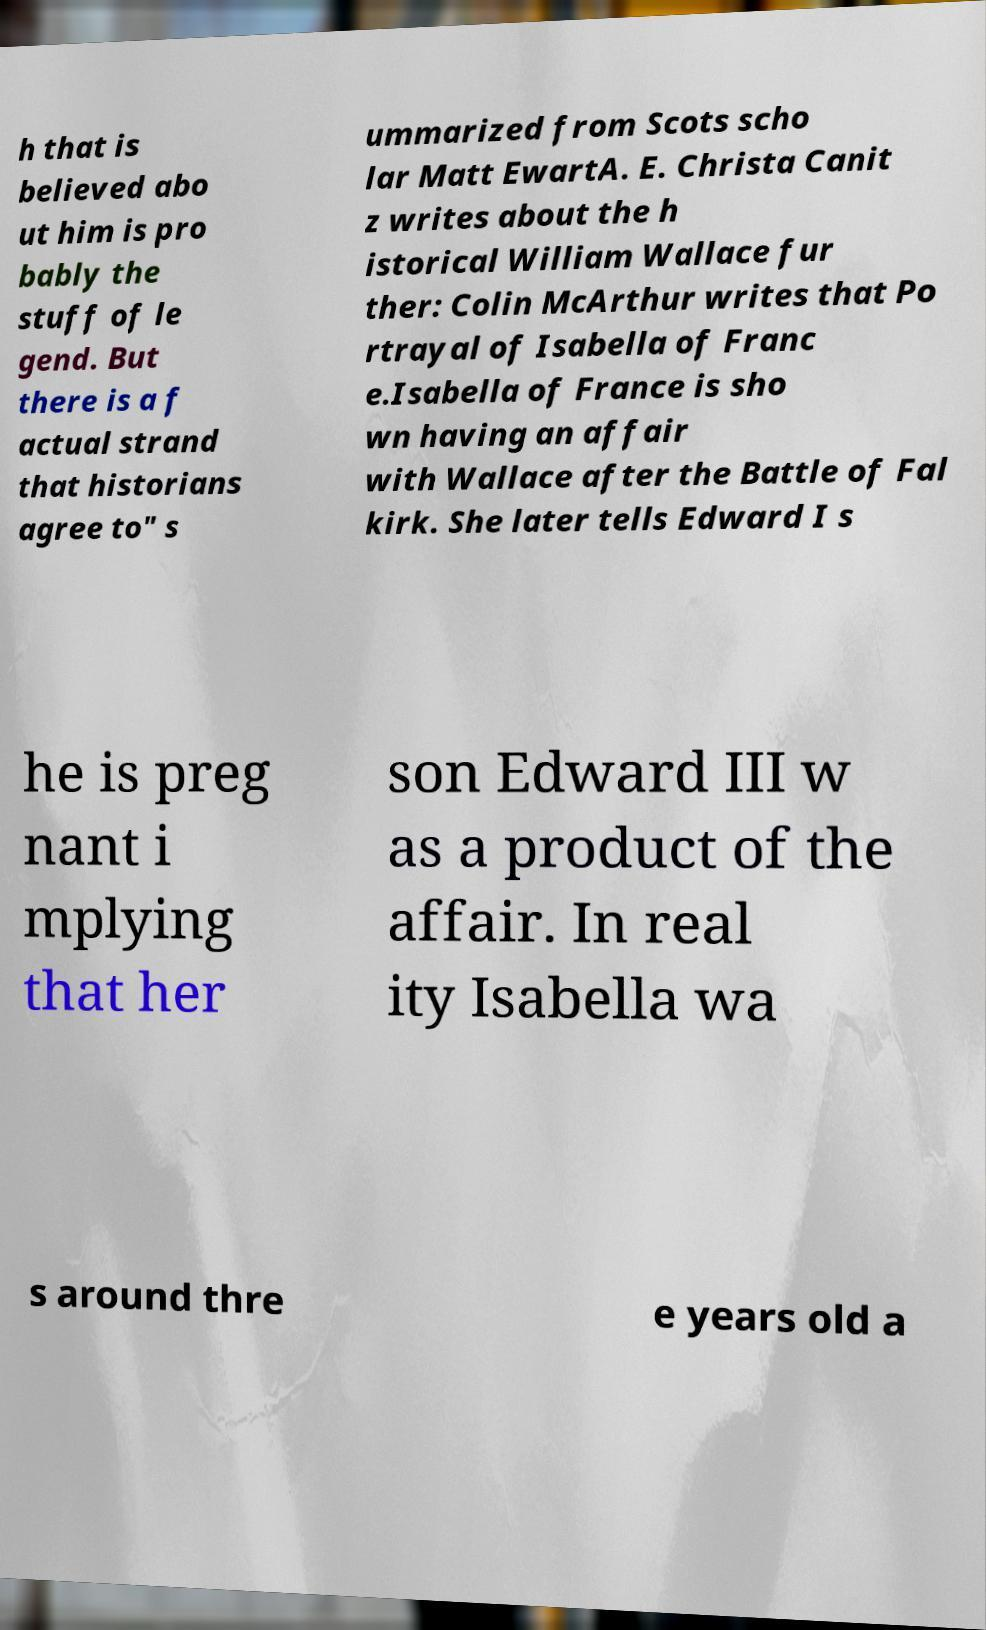Could you extract and type out the text from this image? h that is believed abo ut him is pro bably the stuff of le gend. But there is a f actual strand that historians agree to" s ummarized from Scots scho lar Matt EwartA. E. Christa Canit z writes about the h istorical William Wallace fur ther: Colin McArthur writes that Po rtrayal of Isabella of Franc e.Isabella of France is sho wn having an affair with Wallace after the Battle of Fal kirk. She later tells Edward I s he is preg nant i mplying that her son Edward III w as a product of the affair. In real ity Isabella wa s around thre e years old a 